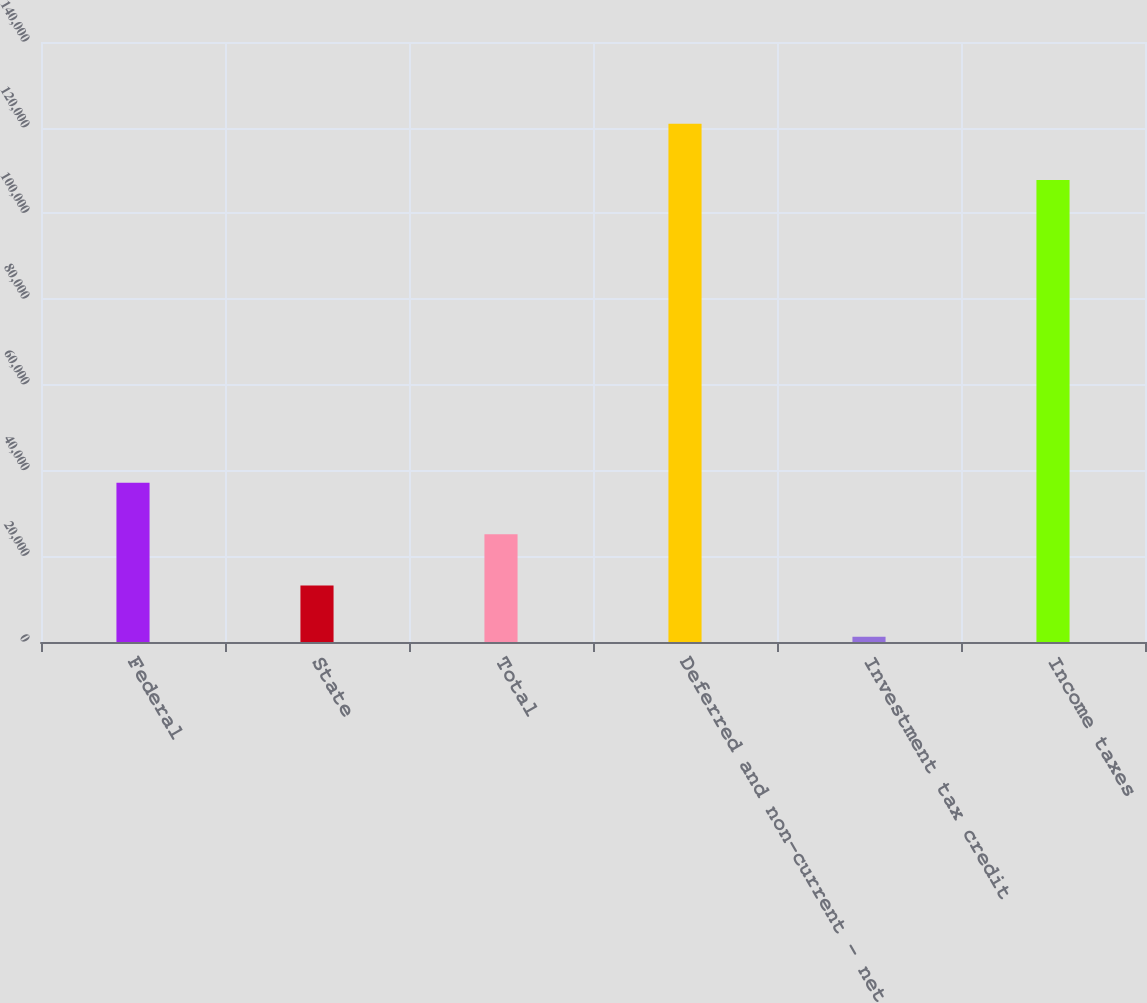Convert chart. <chart><loc_0><loc_0><loc_500><loc_500><bar_chart><fcel>Federal<fcel>State<fcel>Total<fcel>Deferred and non-current - net<fcel>Investment tax credit<fcel>Income taxes<nl><fcel>37140.8<fcel>13197.6<fcel>25169.2<fcel>120942<fcel>1226<fcel>107773<nl></chart> 